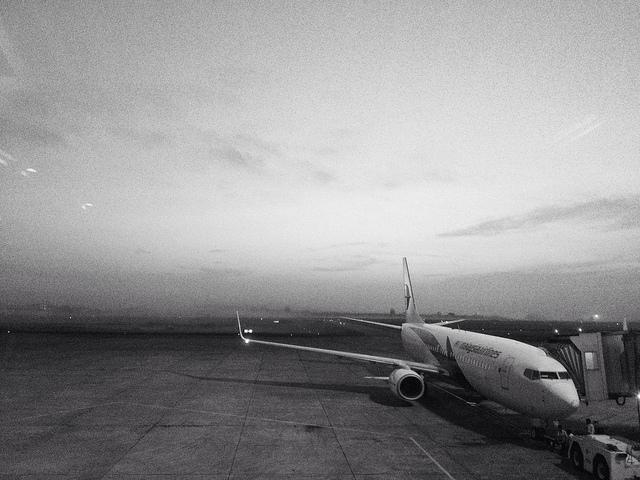What time is it on the image? Please explain your reasoning. night. A plane is on a runway with dark skies behind it. skies are dark at night. 